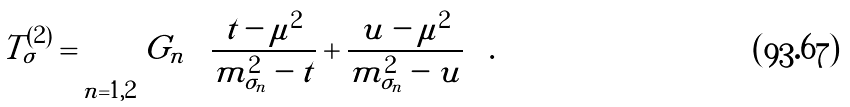<formula> <loc_0><loc_0><loc_500><loc_500>T ^ { ( 2 ) } _ { \sigma } = \sum _ { n = 1 , 2 } G _ { n } \left ( \frac { t - \mu ^ { 2 } } { m ^ { 2 } _ { \sigma _ { n } } - t } + \frac { u - \mu ^ { 2 } } { m ^ { 2 } _ { \sigma _ { n } } - u } \right ) .</formula> 